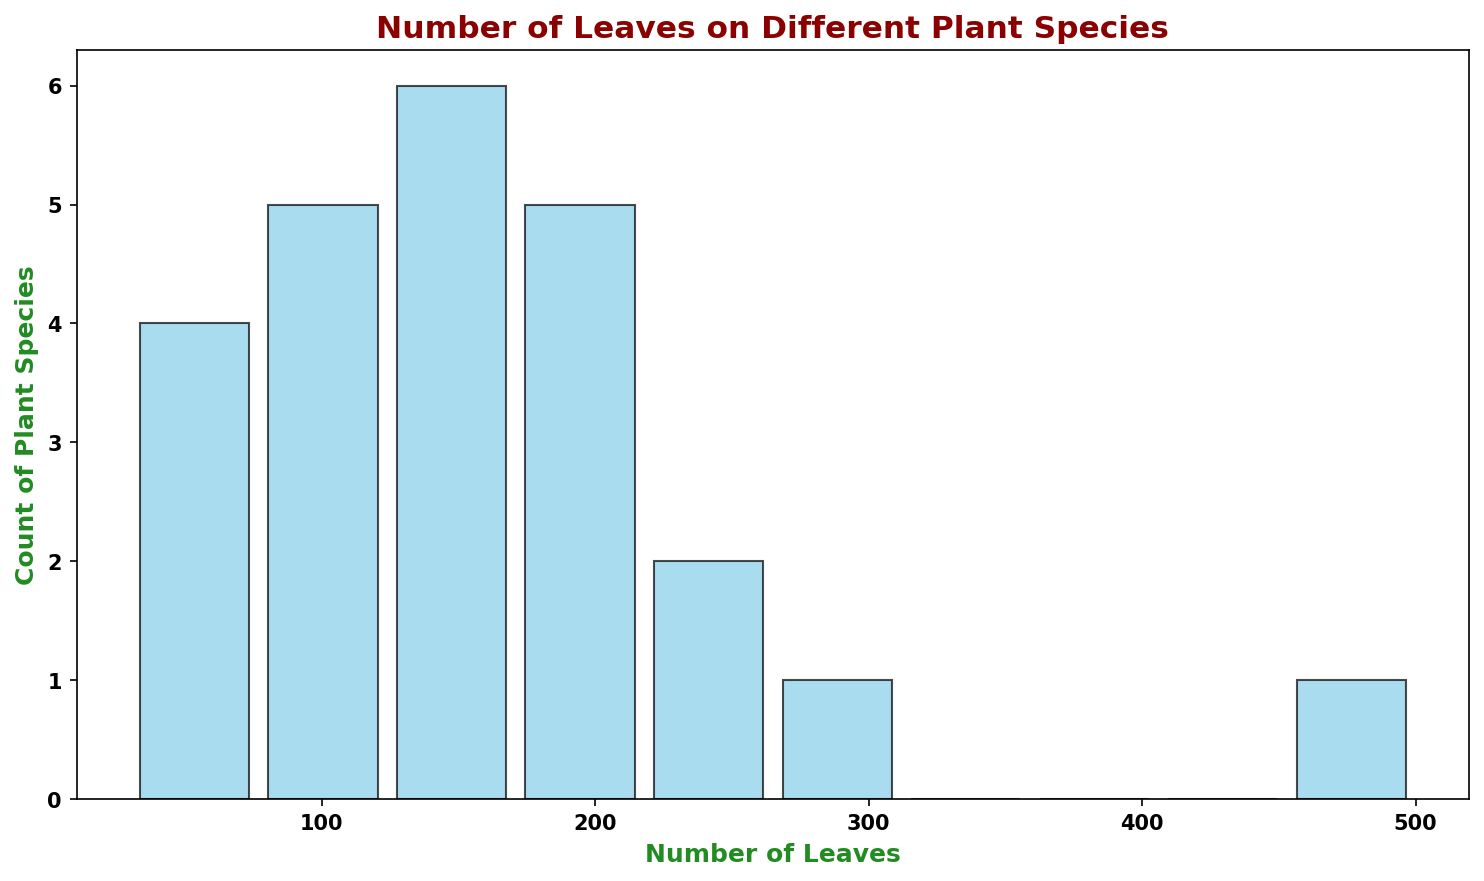Which range has the highest count of plant species? Looking at the histogram, identify the bin with the tallest bar, which indicates that it represents the range with the highest count of plant species.
Answer: 190-220 Which range has the lowest count of plant species? Identify the bin with the shortest bar, which means that it has the lowest count of plant species.
Answer: 460-500 How many plant species have between 100 and 150 leaves? Count the number of species in the bin that covers the range 100 to 150 leaves.
Answer: 6 What is the total count of plant species with more than 200 leaves? Add the counts of all bins that have a range starting from 200 leaves and higher.
Answer: 6 Is the number of species with leaves between 50 and 100 greater than those between 300 and 500? Compare the counts of species in the 50-100 leaves range bin with those in the 300-500 leaves range bins.
Answer: Yes Which range(s) of leaves has an exactly equal count of plant species? Identify any bins that have bars of the exact same height.
Answer: 180-210 and 210-240 What is the difference in counts between the range 30-60 and 60-90? Subtract the count of the 60-90 range bin from the 30-60 range bin.
Answer: 1 What is the average number of leaves for the plant species in the most populated bin? Identify the bin with the highest count, then find the midpoint of that range, which gives the average number of leaves for that bin.
Answer: 205 Are there more plant species with fewer than 100 leaves or more than 300 leaves? Compare the summed counts of species in bins less than 100 leaves with those having more than 300 leaves.
Answer: Fewer than 100 leaves 